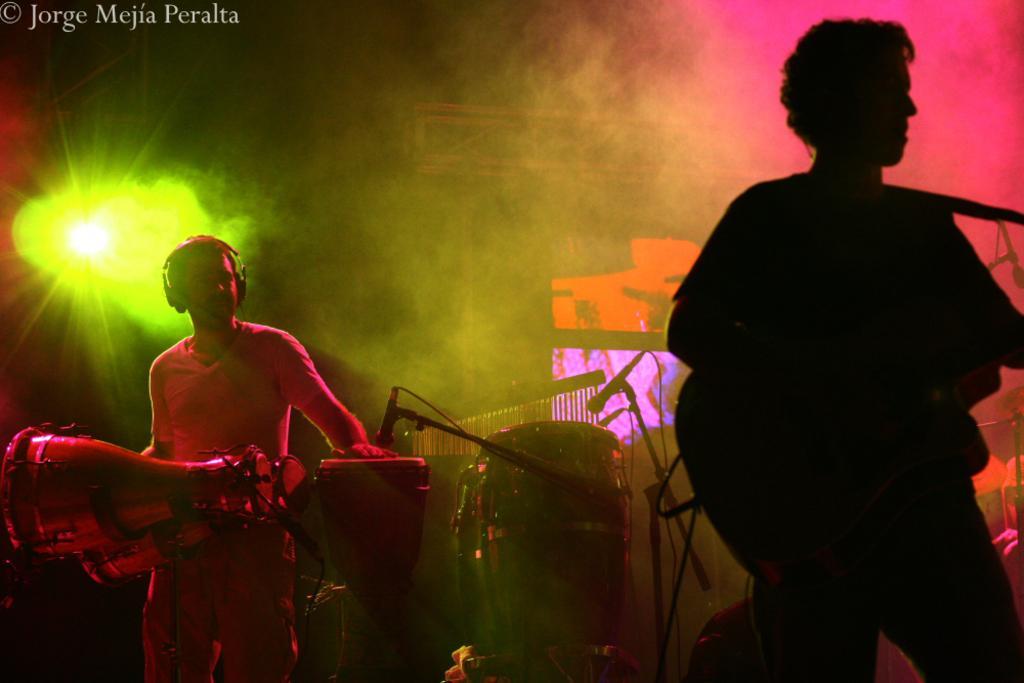How would you summarize this image in a sentence or two? In this image i can see a person standing and holding a guitar in his hand and to the left of the image and see a person wearing a t-shirt and pant standing in front of few musical instruments is wearing a headset. I can see few microphones in front of them. In the background I can see few screens and a light. 